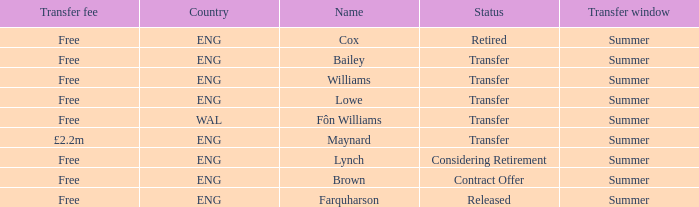What is the name of the free transfer fee with a transfer status and an ENG country? Bailey, Williams, Lowe. 